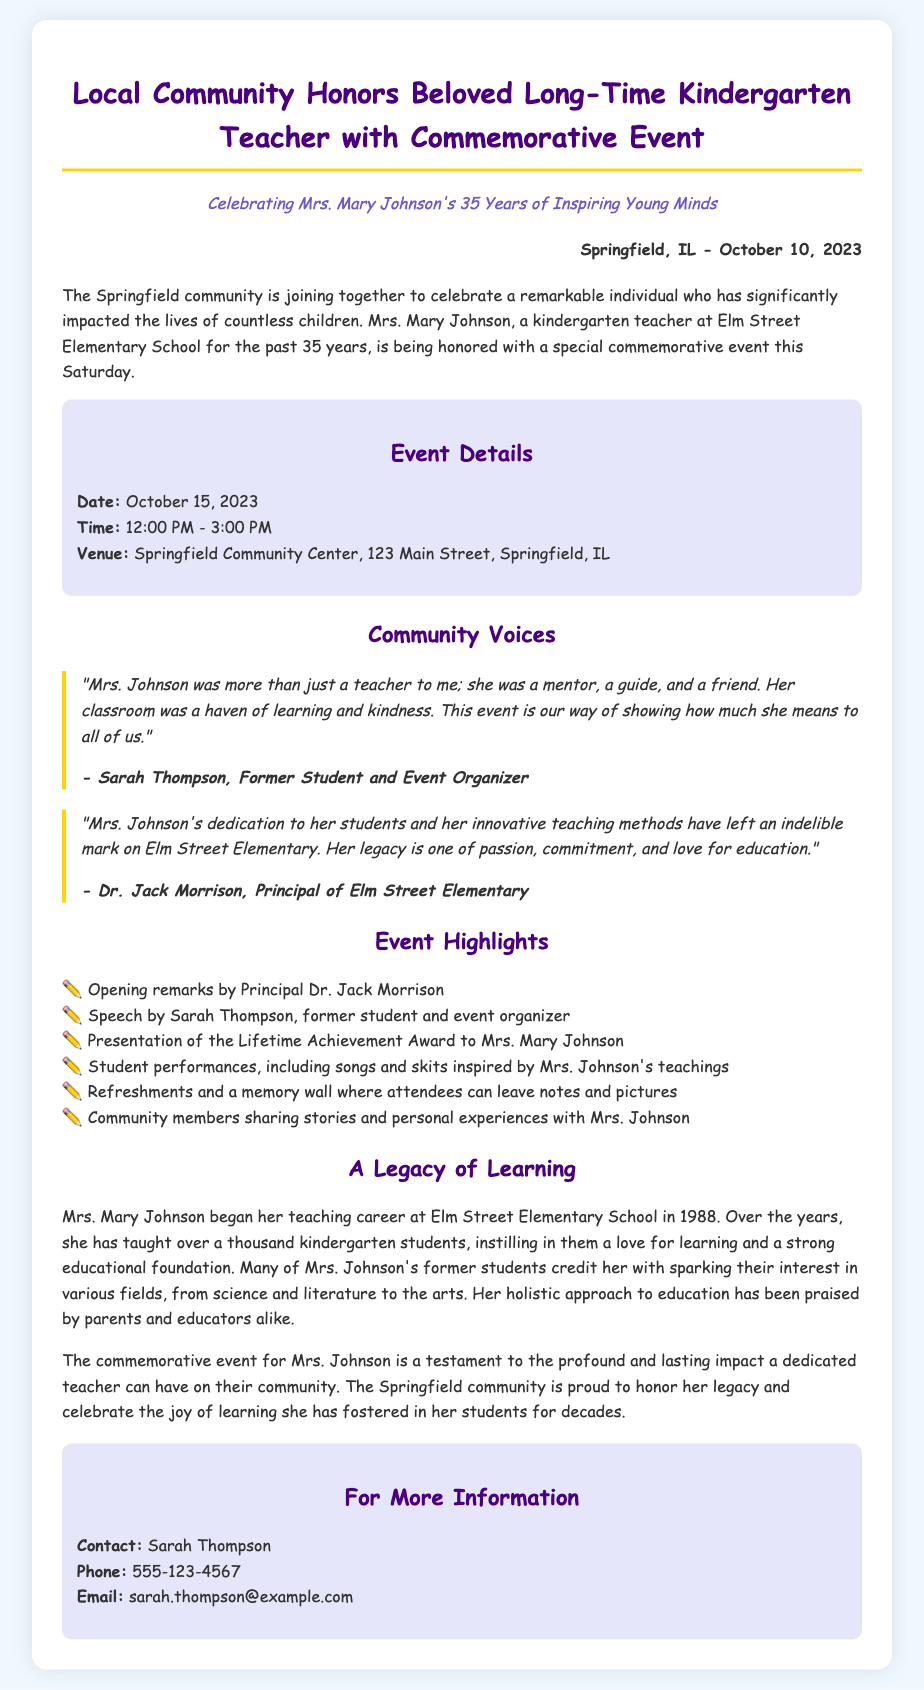What is the name of the teacher being honored? The name of the teacher being honored is mentioned in the title and first paragraph of the document, which refers to Mrs. Mary Johnson.
Answer: Mrs. Mary Johnson How many years did Mrs. Johnson teach? The document specifies that Mrs. Johnson has taught for 35 years, highlighted in the subheadline of the press release.
Answer: 35 years When will the commemorative event take place? The event date is mentioned in the event details section, providing clear information about when it occurs.
Answer: October 15, 2023 Where is the event being held? The venue of the event is detailed in the event details section, giving the specific location for the commemorative event.
Answer: Springfield Community Center Who is organizing the event? The document quotes Sarah Thompson as a former student and event organizer, indicating her role in organizing the activity.
Answer: Sarah Thompson What award will Mrs. Johnson receive at the event? The document states that Mrs. Johnson will be presented with a Lifetime Achievement Award during the event.
Answer: Lifetime Achievement Award What type of performances will occur at the event? The event highlights mention that student performances will include songs and skits, inspired by Mrs. Johnson's teachings.
Answer: Songs and skits What is one reason the community is honoring Mrs. Johnson? The document explains that Mrs. Johnson's legacy is praised for her passion, commitment, and love for education, which is why the community wants to honor her.
Answer: Passion, commitment, and love for education Who is the contact person for more information? The contact information section indicates that Sarah Thompson is the person to reach out to for further details regarding the event.
Answer: Sarah Thompson 